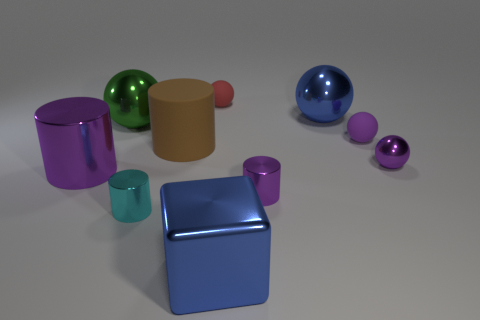There is a big cylinder in front of the brown matte cylinder; does it have the same color as the small metal sphere?
Your answer should be compact. Yes. Is there anything else that has the same size as the red rubber thing?
Offer a terse response. Yes. There is a small purple metallic object that is on the left side of the purple matte object; is its shape the same as the purple thing that is behind the brown cylinder?
Give a very brief answer. No. There is a brown rubber thing that is the same size as the green object; what is its shape?
Provide a succinct answer. Cylinder. Is the number of big metal cubes to the left of the large green shiny ball the same as the number of big purple metal objects that are in front of the large blue block?
Make the answer very short. Yes. Are there any other things that are the same shape as the small purple rubber thing?
Offer a very short reply. Yes. Is the material of the big blue object in front of the big blue metal sphere the same as the red sphere?
Ensure brevity in your answer.  No. There is another cylinder that is the same size as the matte cylinder; what material is it?
Your answer should be very brief. Metal. What number of other things are made of the same material as the big brown cylinder?
Give a very brief answer. 2. There is a purple metallic ball; is its size the same as the blue thing behind the small cyan shiny object?
Give a very brief answer. No. 